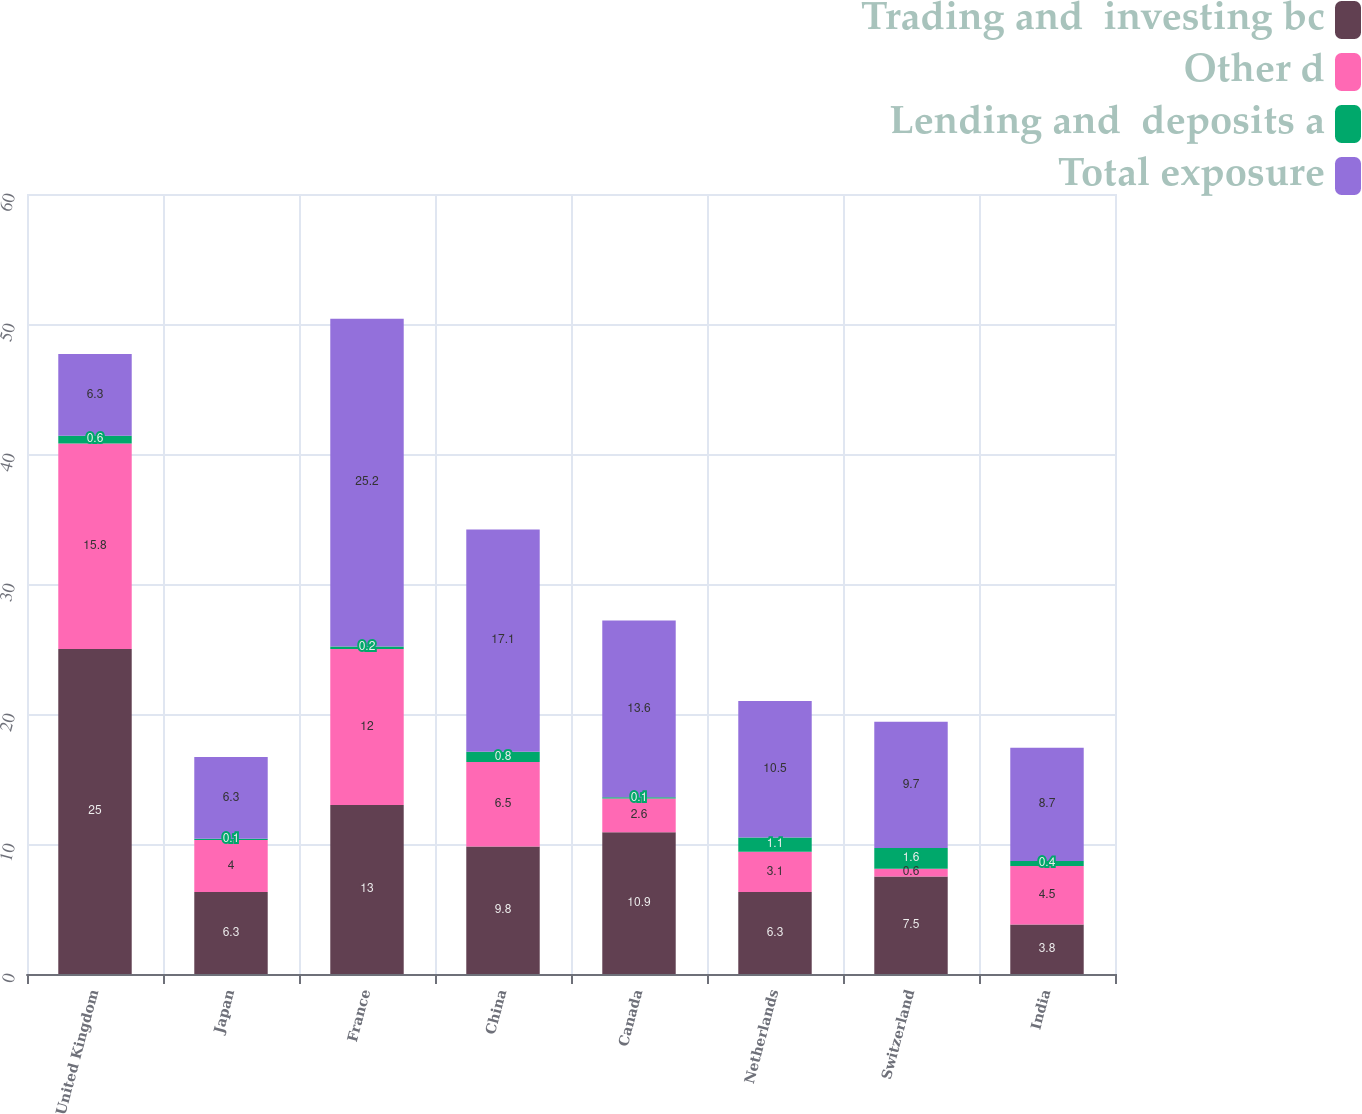Convert chart to OTSL. <chart><loc_0><loc_0><loc_500><loc_500><stacked_bar_chart><ecel><fcel>United Kingdom<fcel>Japan<fcel>France<fcel>China<fcel>Canada<fcel>Netherlands<fcel>Switzerland<fcel>India<nl><fcel>Trading and  investing bc<fcel>25<fcel>6.3<fcel>13<fcel>9.8<fcel>10.9<fcel>6.3<fcel>7.5<fcel>3.8<nl><fcel>Other d<fcel>15.8<fcel>4<fcel>12<fcel>6.5<fcel>2.6<fcel>3.1<fcel>0.6<fcel>4.5<nl><fcel>Lending and  deposits a<fcel>0.6<fcel>0.1<fcel>0.2<fcel>0.8<fcel>0.1<fcel>1.1<fcel>1.6<fcel>0.4<nl><fcel>Total exposure<fcel>6.3<fcel>6.3<fcel>25.2<fcel>17.1<fcel>13.6<fcel>10.5<fcel>9.7<fcel>8.7<nl></chart> 